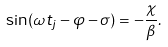Convert formula to latex. <formula><loc_0><loc_0><loc_500><loc_500>\sin ( \omega t _ { j } - \varphi - \sigma ) = - \frac { \chi } { \beta } .</formula> 